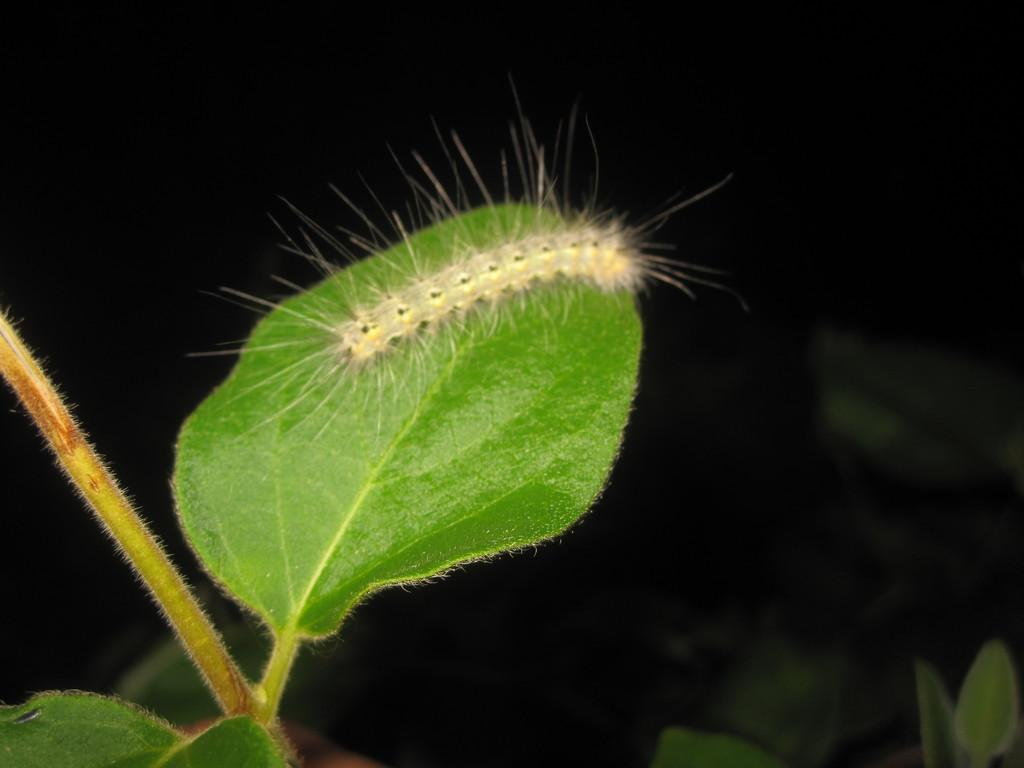What is the main subject of the image? The main subject of the image is a stem with leaves. Is there anything else present on the stem or leaves? Yes, there is a caterpillar on one of the leaves. What can be observed about the background of the image? The background of the image is dark. How many fingers can be seen in the image? There are no fingers visible in the image. Are there any snails present in the image? There are no snails present in the image. 